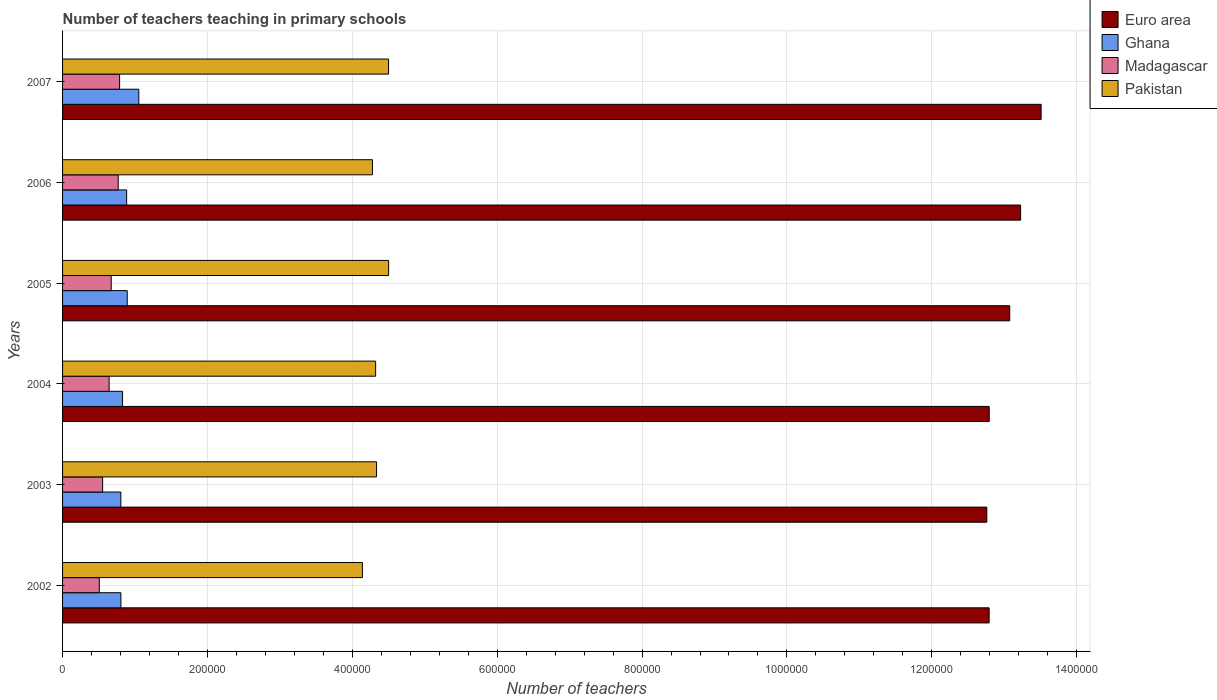How many groups of bars are there?
Offer a terse response. 6. What is the label of the 4th group of bars from the top?
Keep it short and to the point. 2004. In how many cases, is the number of bars for a given year not equal to the number of legend labels?
Offer a terse response. 0. What is the number of teachers teaching in primary schools in Ghana in 2002?
Provide a succinct answer. 8.06e+04. Across all years, what is the maximum number of teachers teaching in primary schools in Euro area?
Offer a terse response. 1.35e+06. Across all years, what is the minimum number of teachers teaching in primary schools in Pakistan?
Keep it short and to the point. 4.14e+05. In which year was the number of teachers teaching in primary schools in Euro area maximum?
Provide a succinct answer. 2007. In which year was the number of teachers teaching in primary schools in Madagascar minimum?
Give a very brief answer. 2002. What is the total number of teachers teaching in primary schools in Madagascar in the graph?
Provide a succinct answer. 3.93e+05. What is the difference between the number of teachers teaching in primary schools in Pakistan in 2003 and that in 2004?
Offer a terse response. 1239. What is the difference between the number of teachers teaching in primary schools in Pakistan in 2006 and the number of teachers teaching in primary schools in Ghana in 2005?
Give a very brief answer. 3.39e+05. What is the average number of teachers teaching in primary schools in Ghana per year?
Keep it short and to the point. 8.78e+04. In the year 2004, what is the difference between the number of teachers teaching in primary schools in Madagascar and number of teachers teaching in primary schools in Euro area?
Give a very brief answer. -1.22e+06. What is the ratio of the number of teachers teaching in primary schools in Pakistan in 2002 to that in 2006?
Your response must be concise. 0.97. Is the difference between the number of teachers teaching in primary schools in Madagascar in 2005 and 2007 greater than the difference between the number of teachers teaching in primary schools in Euro area in 2005 and 2007?
Provide a succinct answer. Yes. What is the difference between the highest and the second highest number of teachers teaching in primary schools in Euro area?
Offer a very short reply. 2.83e+04. What is the difference between the highest and the lowest number of teachers teaching in primary schools in Pakistan?
Your answer should be compact. 3.62e+04. What does the 4th bar from the top in 2007 represents?
Offer a terse response. Euro area. Is it the case that in every year, the sum of the number of teachers teaching in primary schools in Pakistan and number of teachers teaching in primary schools in Ghana is greater than the number of teachers teaching in primary schools in Madagascar?
Give a very brief answer. Yes. How many bars are there?
Give a very brief answer. 24. What is the difference between two consecutive major ticks on the X-axis?
Provide a short and direct response. 2.00e+05. Does the graph contain any zero values?
Give a very brief answer. No. Where does the legend appear in the graph?
Provide a short and direct response. Top right. How many legend labels are there?
Offer a terse response. 4. What is the title of the graph?
Keep it short and to the point. Number of teachers teaching in primary schools. Does "Grenada" appear as one of the legend labels in the graph?
Provide a succinct answer. No. What is the label or title of the X-axis?
Your response must be concise. Number of teachers. What is the Number of teachers of Euro area in 2002?
Provide a succinct answer. 1.28e+06. What is the Number of teachers of Ghana in 2002?
Provide a short and direct response. 8.06e+04. What is the Number of teachers of Madagascar in 2002?
Your response must be concise. 5.07e+04. What is the Number of teachers in Pakistan in 2002?
Give a very brief answer. 4.14e+05. What is the Number of teachers of Euro area in 2003?
Make the answer very short. 1.28e+06. What is the Number of teachers in Ghana in 2003?
Your response must be concise. 8.05e+04. What is the Number of teachers of Madagascar in 2003?
Make the answer very short. 5.53e+04. What is the Number of teachers in Pakistan in 2003?
Make the answer very short. 4.33e+05. What is the Number of teachers in Euro area in 2004?
Your answer should be very brief. 1.28e+06. What is the Number of teachers in Ghana in 2004?
Your answer should be compact. 8.28e+04. What is the Number of teachers of Madagascar in 2004?
Give a very brief answer. 6.43e+04. What is the Number of teachers of Pakistan in 2004?
Your answer should be compact. 4.32e+05. What is the Number of teachers of Euro area in 2005?
Offer a very short reply. 1.31e+06. What is the Number of teachers of Ghana in 2005?
Offer a terse response. 8.93e+04. What is the Number of teachers in Madagascar in 2005?
Your answer should be very brief. 6.71e+04. What is the Number of teachers in Pakistan in 2005?
Offer a very short reply. 4.50e+05. What is the Number of teachers in Euro area in 2006?
Give a very brief answer. 1.32e+06. What is the Number of teachers in Ghana in 2006?
Give a very brief answer. 8.85e+04. What is the Number of teachers of Madagascar in 2006?
Keep it short and to the point. 7.68e+04. What is the Number of teachers of Pakistan in 2006?
Provide a succinct answer. 4.28e+05. What is the Number of teachers of Euro area in 2007?
Provide a short and direct response. 1.35e+06. What is the Number of teachers in Ghana in 2007?
Your answer should be very brief. 1.05e+05. What is the Number of teachers of Madagascar in 2007?
Your answer should be very brief. 7.87e+04. What is the Number of teachers in Pakistan in 2007?
Your answer should be compact. 4.50e+05. Across all years, what is the maximum Number of teachers of Euro area?
Your response must be concise. 1.35e+06. Across all years, what is the maximum Number of teachers of Ghana?
Ensure brevity in your answer.  1.05e+05. Across all years, what is the maximum Number of teachers of Madagascar?
Your response must be concise. 7.87e+04. Across all years, what is the maximum Number of teachers of Pakistan?
Your answer should be compact. 4.50e+05. Across all years, what is the minimum Number of teachers of Euro area?
Your response must be concise. 1.28e+06. Across all years, what is the minimum Number of teachers in Ghana?
Ensure brevity in your answer.  8.05e+04. Across all years, what is the minimum Number of teachers in Madagascar?
Give a very brief answer. 5.07e+04. Across all years, what is the minimum Number of teachers of Pakistan?
Give a very brief answer. 4.14e+05. What is the total Number of teachers in Euro area in the graph?
Your answer should be compact. 7.82e+06. What is the total Number of teachers of Ghana in the graph?
Make the answer very short. 5.27e+05. What is the total Number of teachers of Madagascar in the graph?
Offer a terse response. 3.93e+05. What is the total Number of teachers in Pakistan in the graph?
Your response must be concise. 2.61e+06. What is the difference between the Number of teachers in Euro area in 2002 and that in 2003?
Provide a short and direct response. 3219.75. What is the difference between the Number of teachers of Ghana in 2002 and that in 2003?
Make the answer very short. 93. What is the difference between the Number of teachers of Madagascar in 2002 and that in 2003?
Provide a succinct answer. -4609. What is the difference between the Number of teachers of Pakistan in 2002 and that in 2003?
Your answer should be compact. -1.95e+04. What is the difference between the Number of teachers of Euro area in 2002 and that in 2004?
Ensure brevity in your answer.  -119.75. What is the difference between the Number of teachers of Ghana in 2002 and that in 2004?
Provide a short and direct response. -2281. What is the difference between the Number of teachers of Madagascar in 2002 and that in 2004?
Your response must be concise. -1.36e+04. What is the difference between the Number of teachers of Pakistan in 2002 and that in 2004?
Your response must be concise. -1.83e+04. What is the difference between the Number of teachers of Euro area in 2002 and that in 2005?
Give a very brief answer. -2.84e+04. What is the difference between the Number of teachers of Ghana in 2002 and that in 2005?
Make the answer very short. -8726. What is the difference between the Number of teachers in Madagascar in 2002 and that in 2005?
Ensure brevity in your answer.  -1.64e+04. What is the difference between the Number of teachers of Pakistan in 2002 and that in 2005?
Provide a short and direct response. -3.62e+04. What is the difference between the Number of teachers of Euro area in 2002 and that in 2006?
Your response must be concise. -4.35e+04. What is the difference between the Number of teachers of Ghana in 2002 and that in 2006?
Provide a succinct answer. -7909. What is the difference between the Number of teachers of Madagascar in 2002 and that in 2006?
Provide a short and direct response. -2.61e+04. What is the difference between the Number of teachers of Pakistan in 2002 and that in 2006?
Provide a succinct answer. -1.39e+04. What is the difference between the Number of teachers of Euro area in 2002 and that in 2007?
Offer a terse response. -7.18e+04. What is the difference between the Number of teachers in Ghana in 2002 and that in 2007?
Keep it short and to the point. -2.47e+04. What is the difference between the Number of teachers in Madagascar in 2002 and that in 2007?
Ensure brevity in your answer.  -2.80e+04. What is the difference between the Number of teachers of Pakistan in 2002 and that in 2007?
Provide a succinct answer. -3.61e+04. What is the difference between the Number of teachers in Euro area in 2003 and that in 2004?
Provide a succinct answer. -3339.5. What is the difference between the Number of teachers of Ghana in 2003 and that in 2004?
Your answer should be very brief. -2374. What is the difference between the Number of teachers in Madagascar in 2003 and that in 2004?
Offer a very short reply. -8961. What is the difference between the Number of teachers in Pakistan in 2003 and that in 2004?
Offer a terse response. 1239. What is the difference between the Number of teachers of Euro area in 2003 and that in 2005?
Offer a very short reply. -3.17e+04. What is the difference between the Number of teachers of Ghana in 2003 and that in 2005?
Make the answer very short. -8819. What is the difference between the Number of teachers in Madagascar in 2003 and that in 2005?
Provide a short and direct response. -1.18e+04. What is the difference between the Number of teachers in Pakistan in 2003 and that in 2005?
Provide a succinct answer. -1.67e+04. What is the difference between the Number of teachers in Euro area in 2003 and that in 2006?
Your response must be concise. -4.67e+04. What is the difference between the Number of teachers in Ghana in 2003 and that in 2006?
Provide a short and direct response. -8002. What is the difference between the Number of teachers of Madagascar in 2003 and that in 2006?
Your response must be concise. -2.15e+04. What is the difference between the Number of teachers in Pakistan in 2003 and that in 2006?
Give a very brief answer. 5631. What is the difference between the Number of teachers in Euro area in 2003 and that in 2007?
Provide a succinct answer. -7.50e+04. What is the difference between the Number of teachers of Ghana in 2003 and that in 2007?
Ensure brevity in your answer.  -2.48e+04. What is the difference between the Number of teachers of Madagascar in 2003 and that in 2007?
Ensure brevity in your answer.  -2.34e+04. What is the difference between the Number of teachers of Pakistan in 2003 and that in 2007?
Ensure brevity in your answer.  -1.66e+04. What is the difference between the Number of teachers of Euro area in 2004 and that in 2005?
Ensure brevity in your answer.  -2.83e+04. What is the difference between the Number of teachers of Ghana in 2004 and that in 2005?
Provide a short and direct response. -6445. What is the difference between the Number of teachers of Madagascar in 2004 and that in 2005?
Your answer should be very brief. -2867. What is the difference between the Number of teachers of Pakistan in 2004 and that in 2005?
Offer a terse response. -1.79e+04. What is the difference between the Number of teachers of Euro area in 2004 and that in 2006?
Offer a terse response. -4.34e+04. What is the difference between the Number of teachers of Ghana in 2004 and that in 2006?
Your answer should be very brief. -5628. What is the difference between the Number of teachers of Madagascar in 2004 and that in 2006?
Provide a succinct answer. -1.26e+04. What is the difference between the Number of teachers in Pakistan in 2004 and that in 2006?
Keep it short and to the point. 4392. What is the difference between the Number of teachers of Euro area in 2004 and that in 2007?
Your response must be concise. -7.16e+04. What is the difference between the Number of teachers in Ghana in 2004 and that in 2007?
Your response must be concise. -2.24e+04. What is the difference between the Number of teachers in Madagascar in 2004 and that in 2007?
Ensure brevity in your answer.  -1.45e+04. What is the difference between the Number of teachers in Pakistan in 2004 and that in 2007?
Your answer should be very brief. -1.78e+04. What is the difference between the Number of teachers in Euro area in 2005 and that in 2006?
Make the answer very short. -1.50e+04. What is the difference between the Number of teachers of Ghana in 2005 and that in 2006?
Your answer should be very brief. 817. What is the difference between the Number of teachers in Madagascar in 2005 and that in 2006?
Your response must be concise. -9694. What is the difference between the Number of teachers of Pakistan in 2005 and that in 2006?
Your answer should be very brief. 2.23e+04. What is the difference between the Number of teachers of Euro area in 2005 and that in 2007?
Provide a succinct answer. -4.33e+04. What is the difference between the Number of teachers in Ghana in 2005 and that in 2007?
Provide a succinct answer. -1.60e+04. What is the difference between the Number of teachers in Madagascar in 2005 and that in 2007?
Make the answer very short. -1.16e+04. What is the difference between the Number of teachers in Pakistan in 2005 and that in 2007?
Make the answer very short. 109. What is the difference between the Number of teachers in Euro area in 2006 and that in 2007?
Your answer should be compact. -2.83e+04. What is the difference between the Number of teachers in Ghana in 2006 and that in 2007?
Make the answer very short. -1.68e+04. What is the difference between the Number of teachers of Madagascar in 2006 and that in 2007?
Ensure brevity in your answer.  -1912. What is the difference between the Number of teachers of Pakistan in 2006 and that in 2007?
Your answer should be compact. -2.22e+04. What is the difference between the Number of teachers in Euro area in 2002 and the Number of teachers in Ghana in 2003?
Provide a succinct answer. 1.20e+06. What is the difference between the Number of teachers in Euro area in 2002 and the Number of teachers in Madagascar in 2003?
Offer a terse response. 1.22e+06. What is the difference between the Number of teachers in Euro area in 2002 and the Number of teachers in Pakistan in 2003?
Give a very brief answer. 8.46e+05. What is the difference between the Number of teachers in Ghana in 2002 and the Number of teachers in Madagascar in 2003?
Make the answer very short. 2.52e+04. What is the difference between the Number of teachers in Ghana in 2002 and the Number of teachers in Pakistan in 2003?
Offer a terse response. -3.53e+05. What is the difference between the Number of teachers in Madagascar in 2002 and the Number of teachers in Pakistan in 2003?
Ensure brevity in your answer.  -3.83e+05. What is the difference between the Number of teachers of Euro area in 2002 and the Number of teachers of Ghana in 2004?
Offer a very short reply. 1.20e+06. What is the difference between the Number of teachers of Euro area in 2002 and the Number of teachers of Madagascar in 2004?
Provide a succinct answer. 1.21e+06. What is the difference between the Number of teachers in Euro area in 2002 and the Number of teachers in Pakistan in 2004?
Provide a short and direct response. 8.47e+05. What is the difference between the Number of teachers in Ghana in 2002 and the Number of teachers in Madagascar in 2004?
Ensure brevity in your answer.  1.63e+04. What is the difference between the Number of teachers of Ghana in 2002 and the Number of teachers of Pakistan in 2004?
Provide a succinct answer. -3.52e+05. What is the difference between the Number of teachers of Madagascar in 2002 and the Number of teachers of Pakistan in 2004?
Your answer should be very brief. -3.82e+05. What is the difference between the Number of teachers in Euro area in 2002 and the Number of teachers in Ghana in 2005?
Offer a very short reply. 1.19e+06. What is the difference between the Number of teachers in Euro area in 2002 and the Number of teachers in Madagascar in 2005?
Offer a terse response. 1.21e+06. What is the difference between the Number of teachers in Euro area in 2002 and the Number of teachers in Pakistan in 2005?
Offer a very short reply. 8.29e+05. What is the difference between the Number of teachers in Ghana in 2002 and the Number of teachers in Madagascar in 2005?
Provide a short and direct response. 1.34e+04. What is the difference between the Number of teachers of Ghana in 2002 and the Number of teachers of Pakistan in 2005?
Offer a terse response. -3.70e+05. What is the difference between the Number of teachers of Madagascar in 2002 and the Number of teachers of Pakistan in 2005?
Your answer should be compact. -3.99e+05. What is the difference between the Number of teachers in Euro area in 2002 and the Number of teachers in Ghana in 2006?
Make the answer very short. 1.19e+06. What is the difference between the Number of teachers of Euro area in 2002 and the Number of teachers of Madagascar in 2006?
Your answer should be compact. 1.20e+06. What is the difference between the Number of teachers in Euro area in 2002 and the Number of teachers in Pakistan in 2006?
Your response must be concise. 8.51e+05. What is the difference between the Number of teachers of Ghana in 2002 and the Number of teachers of Madagascar in 2006?
Keep it short and to the point. 3721. What is the difference between the Number of teachers in Ghana in 2002 and the Number of teachers in Pakistan in 2006?
Offer a very short reply. -3.47e+05. What is the difference between the Number of teachers in Madagascar in 2002 and the Number of teachers in Pakistan in 2006?
Give a very brief answer. -3.77e+05. What is the difference between the Number of teachers in Euro area in 2002 and the Number of teachers in Ghana in 2007?
Keep it short and to the point. 1.17e+06. What is the difference between the Number of teachers of Euro area in 2002 and the Number of teachers of Madagascar in 2007?
Your answer should be very brief. 1.20e+06. What is the difference between the Number of teachers of Euro area in 2002 and the Number of teachers of Pakistan in 2007?
Provide a short and direct response. 8.29e+05. What is the difference between the Number of teachers of Ghana in 2002 and the Number of teachers of Madagascar in 2007?
Offer a terse response. 1809. What is the difference between the Number of teachers in Ghana in 2002 and the Number of teachers in Pakistan in 2007?
Offer a terse response. -3.69e+05. What is the difference between the Number of teachers of Madagascar in 2002 and the Number of teachers of Pakistan in 2007?
Offer a terse response. -3.99e+05. What is the difference between the Number of teachers of Euro area in 2003 and the Number of teachers of Ghana in 2004?
Your answer should be compact. 1.19e+06. What is the difference between the Number of teachers of Euro area in 2003 and the Number of teachers of Madagascar in 2004?
Make the answer very short. 1.21e+06. What is the difference between the Number of teachers in Euro area in 2003 and the Number of teachers in Pakistan in 2004?
Your answer should be compact. 8.44e+05. What is the difference between the Number of teachers of Ghana in 2003 and the Number of teachers of Madagascar in 2004?
Offer a very short reply. 1.62e+04. What is the difference between the Number of teachers in Ghana in 2003 and the Number of teachers in Pakistan in 2004?
Your answer should be very brief. -3.52e+05. What is the difference between the Number of teachers in Madagascar in 2003 and the Number of teachers in Pakistan in 2004?
Provide a succinct answer. -3.77e+05. What is the difference between the Number of teachers in Euro area in 2003 and the Number of teachers in Ghana in 2005?
Provide a short and direct response. 1.19e+06. What is the difference between the Number of teachers of Euro area in 2003 and the Number of teachers of Madagascar in 2005?
Offer a terse response. 1.21e+06. What is the difference between the Number of teachers of Euro area in 2003 and the Number of teachers of Pakistan in 2005?
Make the answer very short. 8.26e+05. What is the difference between the Number of teachers in Ghana in 2003 and the Number of teachers in Madagascar in 2005?
Offer a terse response. 1.33e+04. What is the difference between the Number of teachers of Ghana in 2003 and the Number of teachers of Pakistan in 2005?
Ensure brevity in your answer.  -3.70e+05. What is the difference between the Number of teachers of Madagascar in 2003 and the Number of teachers of Pakistan in 2005?
Your response must be concise. -3.95e+05. What is the difference between the Number of teachers of Euro area in 2003 and the Number of teachers of Ghana in 2006?
Give a very brief answer. 1.19e+06. What is the difference between the Number of teachers of Euro area in 2003 and the Number of teachers of Madagascar in 2006?
Offer a terse response. 1.20e+06. What is the difference between the Number of teachers in Euro area in 2003 and the Number of teachers in Pakistan in 2006?
Keep it short and to the point. 8.48e+05. What is the difference between the Number of teachers of Ghana in 2003 and the Number of teachers of Madagascar in 2006?
Your answer should be compact. 3628. What is the difference between the Number of teachers in Ghana in 2003 and the Number of teachers in Pakistan in 2006?
Ensure brevity in your answer.  -3.47e+05. What is the difference between the Number of teachers in Madagascar in 2003 and the Number of teachers in Pakistan in 2006?
Make the answer very short. -3.73e+05. What is the difference between the Number of teachers in Euro area in 2003 and the Number of teachers in Ghana in 2007?
Give a very brief answer. 1.17e+06. What is the difference between the Number of teachers in Euro area in 2003 and the Number of teachers in Madagascar in 2007?
Offer a terse response. 1.20e+06. What is the difference between the Number of teachers of Euro area in 2003 and the Number of teachers of Pakistan in 2007?
Keep it short and to the point. 8.26e+05. What is the difference between the Number of teachers of Ghana in 2003 and the Number of teachers of Madagascar in 2007?
Keep it short and to the point. 1716. What is the difference between the Number of teachers in Ghana in 2003 and the Number of teachers in Pakistan in 2007?
Your answer should be compact. -3.70e+05. What is the difference between the Number of teachers of Madagascar in 2003 and the Number of teachers of Pakistan in 2007?
Make the answer very short. -3.95e+05. What is the difference between the Number of teachers in Euro area in 2004 and the Number of teachers in Ghana in 2005?
Provide a succinct answer. 1.19e+06. What is the difference between the Number of teachers of Euro area in 2004 and the Number of teachers of Madagascar in 2005?
Your response must be concise. 1.21e+06. What is the difference between the Number of teachers of Euro area in 2004 and the Number of teachers of Pakistan in 2005?
Provide a succinct answer. 8.29e+05. What is the difference between the Number of teachers of Ghana in 2004 and the Number of teachers of Madagascar in 2005?
Keep it short and to the point. 1.57e+04. What is the difference between the Number of teachers in Ghana in 2004 and the Number of teachers in Pakistan in 2005?
Your answer should be compact. -3.67e+05. What is the difference between the Number of teachers in Madagascar in 2004 and the Number of teachers in Pakistan in 2005?
Offer a terse response. -3.86e+05. What is the difference between the Number of teachers of Euro area in 2004 and the Number of teachers of Ghana in 2006?
Your answer should be compact. 1.19e+06. What is the difference between the Number of teachers in Euro area in 2004 and the Number of teachers in Madagascar in 2006?
Keep it short and to the point. 1.20e+06. What is the difference between the Number of teachers of Euro area in 2004 and the Number of teachers of Pakistan in 2006?
Offer a terse response. 8.51e+05. What is the difference between the Number of teachers in Ghana in 2004 and the Number of teachers in Madagascar in 2006?
Keep it short and to the point. 6002. What is the difference between the Number of teachers of Ghana in 2004 and the Number of teachers of Pakistan in 2006?
Your answer should be very brief. -3.45e+05. What is the difference between the Number of teachers of Madagascar in 2004 and the Number of teachers of Pakistan in 2006?
Give a very brief answer. -3.64e+05. What is the difference between the Number of teachers in Euro area in 2004 and the Number of teachers in Ghana in 2007?
Offer a very short reply. 1.17e+06. What is the difference between the Number of teachers in Euro area in 2004 and the Number of teachers in Madagascar in 2007?
Keep it short and to the point. 1.20e+06. What is the difference between the Number of teachers of Euro area in 2004 and the Number of teachers of Pakistan in 2007?
Keep it short and to the point. 8.29e+05. What is the difference between the Number of teachers of Ghana in 2004 and the Number of teachers of Madagascar in 2007?
Give a very brief answer. 4090. What is the difference between the Number of teachers of Ghana in 2004 and the Number of teachers of Pakistan in 2007?
Provide a short and direct response. -3.67e+05. What is the difference between the Number of teachers in Madagascar in 2004 and the Number of teachers in Pakistan in 2007?
Offer a very short reply. -3.86e+05. What is the difference between the Number of teachers in Euro area in 2005 and the Number of teachers in Ghana in 2006?
Ensure brevity in your answer.  1.22e+06. What is the difference between the Number of teachers of Euro area in 2005 and the Number of teachers of Madagascar in 2006?
Your answer should be compact. 1.23e+06. What is the difference between the Number of teachers of Euro area in 2005 and the Number of teachers of Pakistan in 2006?
Ensure brevity in your answer.  8.80e+05. What is the difference between the Number of teachers in Ghana in 2005 and the Number of teachers in Madagascar in 2006?
Your response must be concise. 1.24e+04. What is the difference between the Number of teachers of Ghana in 2005 and the Number of teachers of Pakistan in 2006?
Provide a short and direct response. -3.39e+05. What is the difference between the Number of teachers of Madagascar in 2005 and the Number of teachers of Pakistan in 2006?
Ensure brevity in your answer.  -3.61e+05. What is the difference between the Number of teachers of Euro area in 2005 and the Number of teachers of Ghana in 2007?
Your response must be concise. 1.20e+06. What is the difference between the Number of teachers in Euro area in 2005 and the Number of teachers in Madagascar in 2007?
Your answer should be very brief. 1.23e+06. What is the difference between the Number of teachers of Euro area in 2005 and the Number of teachers of Pakistan in 2007?
Your answer should be very brief. 8.58e+05. What is the difference between the Number of teachers of Ghana in 2005 and the Number of teachers of Madagascar in 2007?
Offer a very short reply. 1.05e+04. What is the difference between the Number of teachers of Ghana in 2005 and the Number of teachers of Pakistan in 2007?
Keep it short and to the point. -3.61e+05. What is the difference between the Number of teachers of Madagascar in 2005 and the Number of teachers of Pakistan in 2007?
Make the answer very short. -3.83e+05. What is the difference between the Number of teachers in Euro area in 2006 and the Number of teachers in Ghana in 2007?
Ensure brevity in your answer.  1.22e+06. What is the difference between the Number of teachers of Euro area in 2006 and the Number of teachers of Madagascar in 2007?
Make the answer very short. 1.24e+06. What is the difference between the Number of teachers in Euro area in 2006 and the Number of teachers in Pakistan in 2007?
Offer a very short reply. 8.73e+05. What is the difference between the Number of teachers in Ghana in 2006 and the Number of teachers in Madagascar in 2007?
Make the answer very short. 9718. What is the difference between the Number of teachers of Ghana in 2006 and the Number of teachers of Pakistan in 2007?
Offer a terse response. -3.62e+05. What is the difference between the Number of teachers of Madagascar in 2006 and the Number of teachers of Pakistan in 2007?
Your answer should be very brief. -3.73e+05. What is the average Number of teachers of Euro area per year?
Ensure brevity in your answer.  1.30e+06. What is the average Number of teachers in Ghana per year?
Make the answer very short. 8.78e+04. What is the average Number of teachers of Madagascar per year?
Provide a succinct answer. 6.55e+04. What is the average Number of teachers of Pakistan per year?
Give a very brief answer. 4.35e+05. In the year 2002, what is the difference between the Number of teachers of Euro area and Number of teachers of Ghana?
Your response must be concise. 1.20e+06. In the year 2002, what is the difference between the Number of teachers in Euro area and Number of teachers in Madagascar?
Offer a terse response. 1.23e+06. In the year 2002, what is the difference between the Number of teachers in Euro area and Number of teachers in Pakistan?
Keep it short and to the point. 8.65e+05. In the year 2002, what is the difference between the Number of teachers of Ghana and Number of teachers of Madagascar?
Offer a terse response. 2.99e+04. In the year 2002, what is the difference between the Number of teachers of Ghana and Number of teachers of Pakistan?
Keep it short and to the point. -3.33e+05. In the year 2002, what is the difference between the Number of teachers in Madagascar and Number of teachers in Pakistan?
Your response must be concise. -3.63e+05. In the year 2003, what is the difference between the Number of teachers of Euro area and Number of teachers of Ghana?
Your answer should be compact. 1.20e+06. In the year 2003, what is the difference between the Number of teachers of Euro area and Number of teachers of Madagascar?
Your response must be concise. 1.22e+06. In the year 2003, what is the difference between the Number of teachers of Euro area and Number of teachers of Pakistan?
Ensure brevity in your answer.  8.42e+05. In the year 2003, what is the difference between the Number of teachers in Ghana and Number of teachers in Madagascar?
Offer a terse response. 2.52e+04. In the year 2003, what is the difference between the Number of teachers of Ghana and Number of teachers of Pakistan?
Your answer should be compact. -3.53e+05. In the year 2003, what is the difference between the Number of teachers in Madagascar and Number of teachers in Pakistan?
Your response must be concise. -3.78e+05. In the year 2004, what is the difference between the Number of teachers of Euro area and Number of teachers of Ghana?
Offer a very short reply. 1.20e+06. In the year 2004, what is the difference between the Number of teachers of Euro area and Number of teachers of Madagascar?
Your answer should be very brief. 1.22e+06. In the year 2004, what is the difference between the Number of teachers of Euro area and Number of teachers of Pakistan?
Your answer should be compact. 8.47e+05. In the year 2004, what is the difference between the Number of teachers of Ghana and Number of teachers of Madagascar?
Provide a short and direct response. 1.86e+04. In the year 2004, what is the difference between the Number of teachers in Ghana and Number of teachers in Pakistan?
Offer a very short reply. -3.49e+05. In the year 2004, what is the difference between the Number of teachers in Madagascar and Number of teachers in Pakistan?
Provide a short and direct response. -3.68e+05. In the year 2005, what is the difference between the Number of teachers in Euro area and Number of teachers in Ghana?
Make the answer very short. 1.22e+06. In the year 2005, what is the difference between the Number of teachers of Euro area and Number of teachers of Madagascar?
Your answer should be compact. 1.24e+06. In the year 2005, what is the difference between the Number of teachers of Euro area and Number of teachers of Pakistan?
Ensure brevity in your answer.  8.57e+05. In the year 2005, what is the difference between the Number of teachers of Ghana and Number of teachers of Madagascar?
Provide a short and direct response. 2.21e+04. In the year 2005, what is the difference between the Number of teachers in Ghana and Number of teachers in Pakistan?
Make the answer very short. -3.61e+05. In the year 2005, what is the difference between the Number of teachers of Madagascar and Number of teachers of Pakistan?
Your answer should be very brief. -3.83e+05. In the year 2006, what is the difference between the Number of teachers in Euro area and Number of teachers in Ghana?
Your response must be concise. 1.23e+06. In the year 2006, what is the difference between the Number of teachers of Euro area and Number of teachers of Madagascar?
Provide a succinct answer. 1.25e+06. In the year 2006, what is the difference between the Number of teachers in Euro area and Number of teachers in Pakistan?
Ensure brevity in your answer.  8.95e+05. In the year 2006, what is the difference between the Number of teachers of Ghana and Number of teachers of Madagascar?
Make the answer very short. 1.16e+04. In the year 2006, what is the difference between the Number of teachers in Ghana and Number of teachers in Pakistan?
Your answer should be very brief. -3.39e+05. In the year 2006, what is the difference between the Number of teachers in Madagascar and Number of teachers in Pakistan?
Give a very brief answer. -3.51e+05. In the year 2007, what is the difference between the Number of teachers in Euro area and Number of teachers in Ghana?
Provide a succinct answer. 1.25e+06. In the year 2007, what is the difference between the Number of teachers of Euro area and Number of teachers of Madagascar?
Make the answer very short. 1.27e+06. In the year 2007, what is the difference between the Number of teachers in Euro area and Number of teachers in Pakistan?
Your response must be concise. 9.01e+05. In the year 2007, what is the difference between the Number of teachers of Ghana and Number of teachers of Madagascar?
Provide a succinct answer. 2.65e+04. In the year 2007, what is the difference between the Number of teachers in Ghana and Number of teachers in Pakistan?
Your answer should be very brief. -3.45e+05. In the year 2007, what is the difference between the Number of teachers of Madagascar and Number of teachers of Pakistan?
Your answer should be compact. -3.71e+05. What is the ratio of the Number of teachers of Euro area in 2002 to that in 2003?
Provide a short and direct response. 1. What is the ratio of the Number of teachers of Ghana in 2002 to that in 2003?
Your answer should be very brief. 1. What is the ratio of the Number of teachers in Madagascar in 2002 to that in 2003?
Offer a terse response. 0.92. What is the ratio of the Number of teachers of Pakistan in 2002 to that in 2003?
Keep it short and to the point. 0.95. What is the ratio of the Number of teachers in Euro area in 2002 to that in 2004?
Provide a short and direct response. 1. What is the ratio of the Number of teachers of Ghana in 2002 to that in 2004?
Your response must be concise. 0.97. What is the ratio of the Number of teachers of Madagascar in 2002 to that in 2004?
Provide a succinct answer. 0.79. What is the ratio of the Number of teachers of Pakistan in 2002 to that in 2004?
Your answer should be compact. 0.96. What is the ratio of the Number of teachers in Euro area in 2002 to that in 2005?
Make the answer very short. 0.98. What is the ratio of the Number of teachers of Ghana in 2002 to that in 2005?
Keep it short and to the point. 0.9. What is the ratio of the Number of teachers in Madagascar in 2002 to that in 2005?
Give a very brief answer. 0.76. What is the ratio of the Number of teachers in Pakistan in 2002 to that in 2005?
Provide a short and direct response. 0.92. What is the ratio of the Number of teachers of Euro area in 2002 to that in 2006?
Your response must be concise. 0.97. What is the ratio of the Number of teachers in Ghana in 2002 to that in 2006?
Your answer should be compact. 0.91. What is the ratio of the Number of teachers of Madagascar in 2002 to that in 2006?
Your answer should be very brief. 0.66. What is the ratio of the Number of teachers in Pakistan in 2002 to that in 2006?
Your answer should be very brief. 0.97. What is the ratio of the Number of teachers of Euro area in 2002 to that in 2007?
Your answer should be very brief. 0.95. What is the ratio of the Number of teachers in Ghana in 2002 to that in 2007?
Give a very brief answer. 0.77. What is the ratio of the Number of teachers of Madagascar in 2002 to that in 2007?
Your answer should be compact. 0.64. What is the ratio of the Number of teachers of Pakistan in 2002 to that in 2007?
Offer a very short reply. 0.92. What is the ratio of the Number of teachers in Ghana in 2003 to that in 2004?
Keep it short and to the point. 0.97. What is the ratio of the Number of teachers in Madagascar in 2003 to that in 2004?
Ensure brevity in your answer.  0.86. What is the ratio of the Number of teachers in Pakistan in 2003 to that in 2004?
Keep it short and to the point. 1. What is the ratio of the Number of teachers in Euro area in 2003 to that in 2005?
Offer a terse response. 0.98. What is the ratio of the Number of teachers of Ghana in 2003 to that in 2005?
Give a very brief answer. 0.9. What is the ratio of the Number of teachers in Madagascar in 2003 to that in 2005?
Your answer should be very brief. 0.82. What is the ratio of the Number of teachers in Pakistan in 2003 to that in 2005?
Offer a terse response. 0.96. What is the ratio of the Number of teachers of Euro area in 2003 to that in 2006?
Offer a very short reply. 0.96. What is the ratio of the Number of teachers in Ghana in 2003 to that in 2006?
Make the answer very short. 0.91. What is the ratio of the Number of teachers in Madagascar in 2003 to that in 2006?
Make the answer very short. 0.72. What is the ratio of the Number of teachers in Pakistan in 2003 to that in 2006?
Offer a very short reply. 1.01. What is the ratio of the Number of teachers of Euro area in 2003 to that in 2007?
Offer a terse response. 0.94. What is the ratio of the Number of teachers in Ghana in 2003 to that in 2007?
Your answer should be very brief. 0.76. What is the ratio of the Number of teachers in Madagascar in 2003 to that in 2007?
Make the answer very short. 0.7. What is the ratio of the Number of teachers of Pakistan in 2003 to that in 2007?
Offer a terse response. 0.96. What is the ratio of the Number of teachers in Euro area in 2004 to that in 2005?
Your response must be concise. 0.98. What is the ratio of the Number of teachers in Ghana in 2004 to that in 2005?
Your response must be concise. 0.93. What is the ratio of the Number of teachers in Madagascar in 2004 to that in 2005?
Offer a very short reply. 0.96. What is the ratio of the Number of teachers in Pakistan in 2004 to that in 2005?
Offer a terse response. 0.96. What is the ratio of the Number of teachers of Euro area in 2004 to that in 2006?
Offer a terse response. 0.97. What is the ratio of the Number of teachers of Ghana in 2004 to that in 2006?
Give a very brief answer. 0.94. What is the ratio of the Number of teachers of Madagascar in 2004 to that in 2006?
Your answer should be very brief. 0.84. What is the ratio of the Number of teachers in Pakistan in 2004 to that in 2006?
Your response must be concise. 1.01. What is the ratio of the Number of teachers in Euro area in 2004 to that in 2007?
Provide a short and direct response. 0.95. What is the ratio of the Number of teachers in Ghana in 2004 to that in 2007?
Keep it short and to the point. 0.79. What is the ratio of the Number of teachers in Madagascar in 2004 to that in 2007?
Make the answer very short. 0.82. What is the ratio of the Number of teachers in Pakistan in 2004 to that in 2007?
Your answer should be compact. 0.96. What is the ratio of the Number of teachers of Ghana in 2005 to that in 2006?
Provide a short and direct response. 1.01. What is the ratio of the Number of teachers of Madagascar in 2005 to that in 2006?
Make the answer very short. 0.87. What is the ratio of the Number of teachers of Pakistan in 2005 to that in 2006?
Give a very brief answer. 1.05. What is the ratio of the Number of teachers of Euro area in 2005 to that in 2007?
Your answer should be compact. 0.97. What is the ratio of the Number of teachers in Ghana in 2005 to that in 2007?
Offer a terse response. 0.85. What is the ratio of the Number of teachers in Madagascar in 2005 to that in 2007?
Provide a short and direct response. 0.85. What is the ratio of the Number of teachers in Pakistan in 2005 to that in 2007?
Your answer should be compact. 1. What is the ratio of the Number of teachers in Euro area in 2006 to that in 2007?
Offer a very short reply. 0.98. What is the ratio of the Number of teachers of Ghana in 2006 to that in 2007?
Offer a very short reply. 0.84. What is the ratio of the Number of teachers in Madagascar in 2006 to that in 2007?
Your answer should be very brief. 0.98. What is the ratio of the Number of teachers in Pakistan in 2006 to that in 2007?
Provide a succinct answer. 0.95. What is the difference between the highest and the second highest Number of teachers of Euro area?
Provide a succinct answer. 2.83e+04. What is the difference between the highest and the second highest Number of teachers in Ghana?
Keep it short and to the point. 1.60e+04. What is the difference between the highest and the second highest Number of teachers in Madagascar?
Provide a succinct answer. 1912. What is the difference between the highest and the second highest Number of teachers of Pakistan?
Your response must be concise. 109. What is the difference between the highest and the lowest Number of teachers of Euro area?
Your answer should be very brief. 7.50e+04. What is the difference between the highest and the lowest Number of teachers in Ghana?
Your response must be concise. 2.48e+04. What is the difference between the highest and the lowest Number of teachers in Madagascar?
Your response must be concise. 2.80e+04. What is the difference between the highest and the lowest Number of teachers of Pakistan?
Your answer should be very brief. 3.62e+04. 